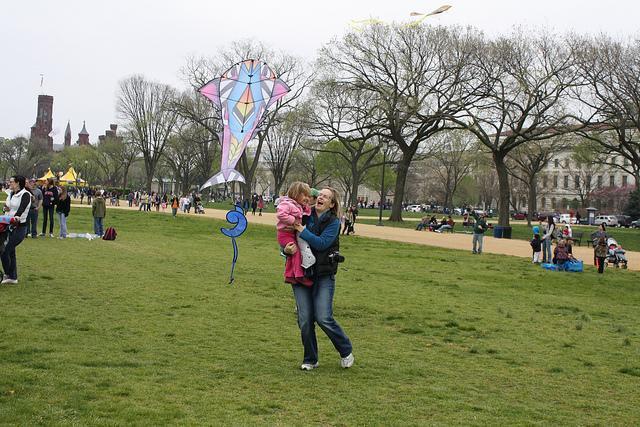How many children are wearing pink coats?
Give a very brief answer. 1. How many people can be seen?
Give a very brief answer. 4. 